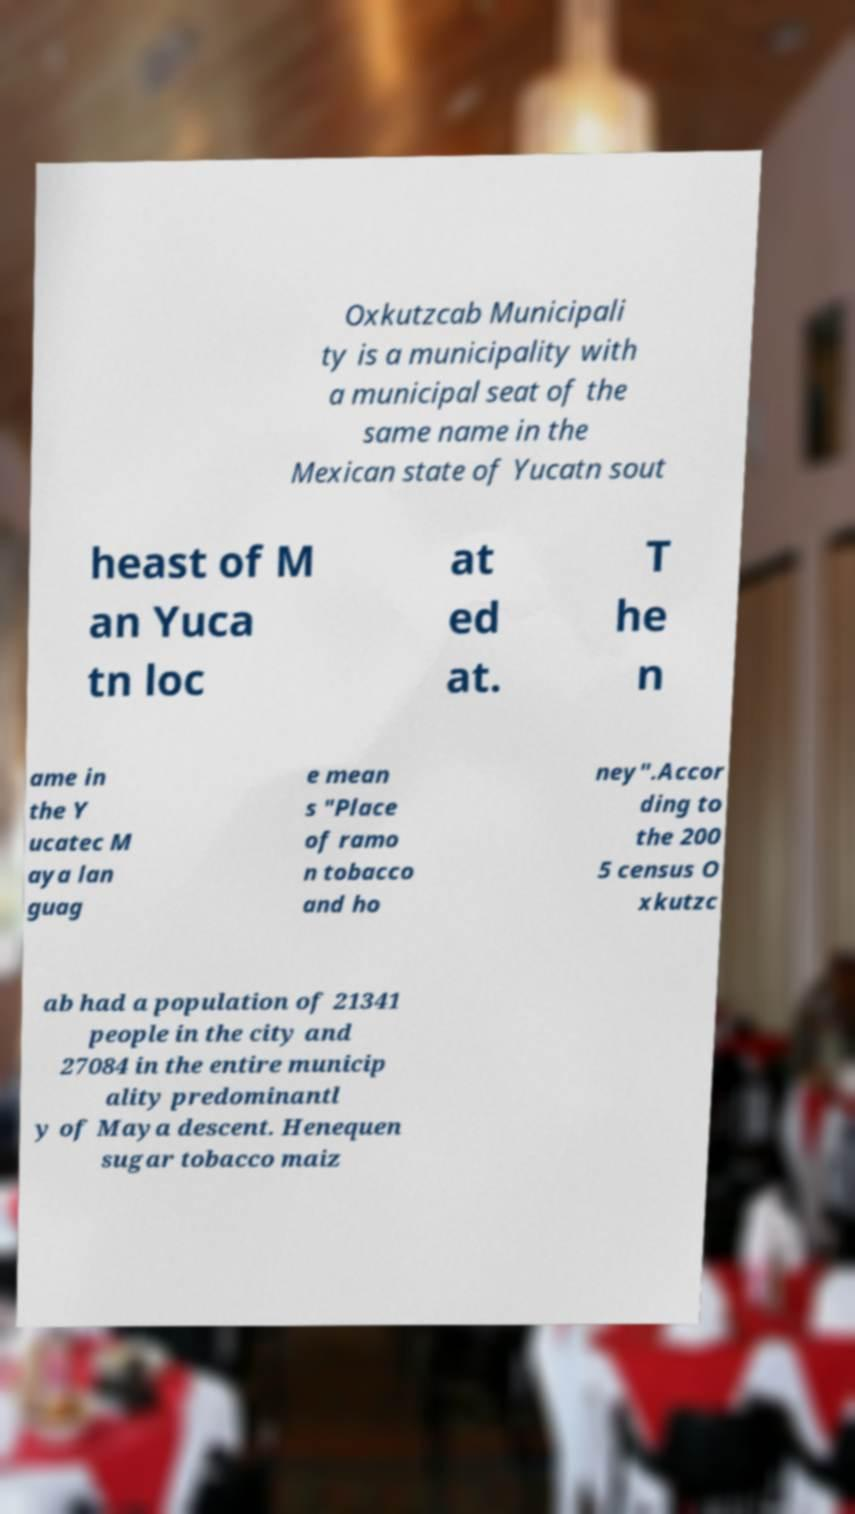There's text embedded in this image that I need extracted. Can you transcribe it verbatim? Oxkutzcab Municipali ty is a municipality with a municipal seat of the same name in the Mexican state of Yucatn sout heast of M an Yuca tn loc at ed at. T he n ame in the Y ucatec M aya lan guag e mean s "Place of ramo n tobacco and ho ney".Accor ding to the 200 5 census O xkutzc ab had a population of 21341 people in the city and 27084 in the entire municip ality predominantl y of Maya descent. Henequen sugar tobacco maiz 